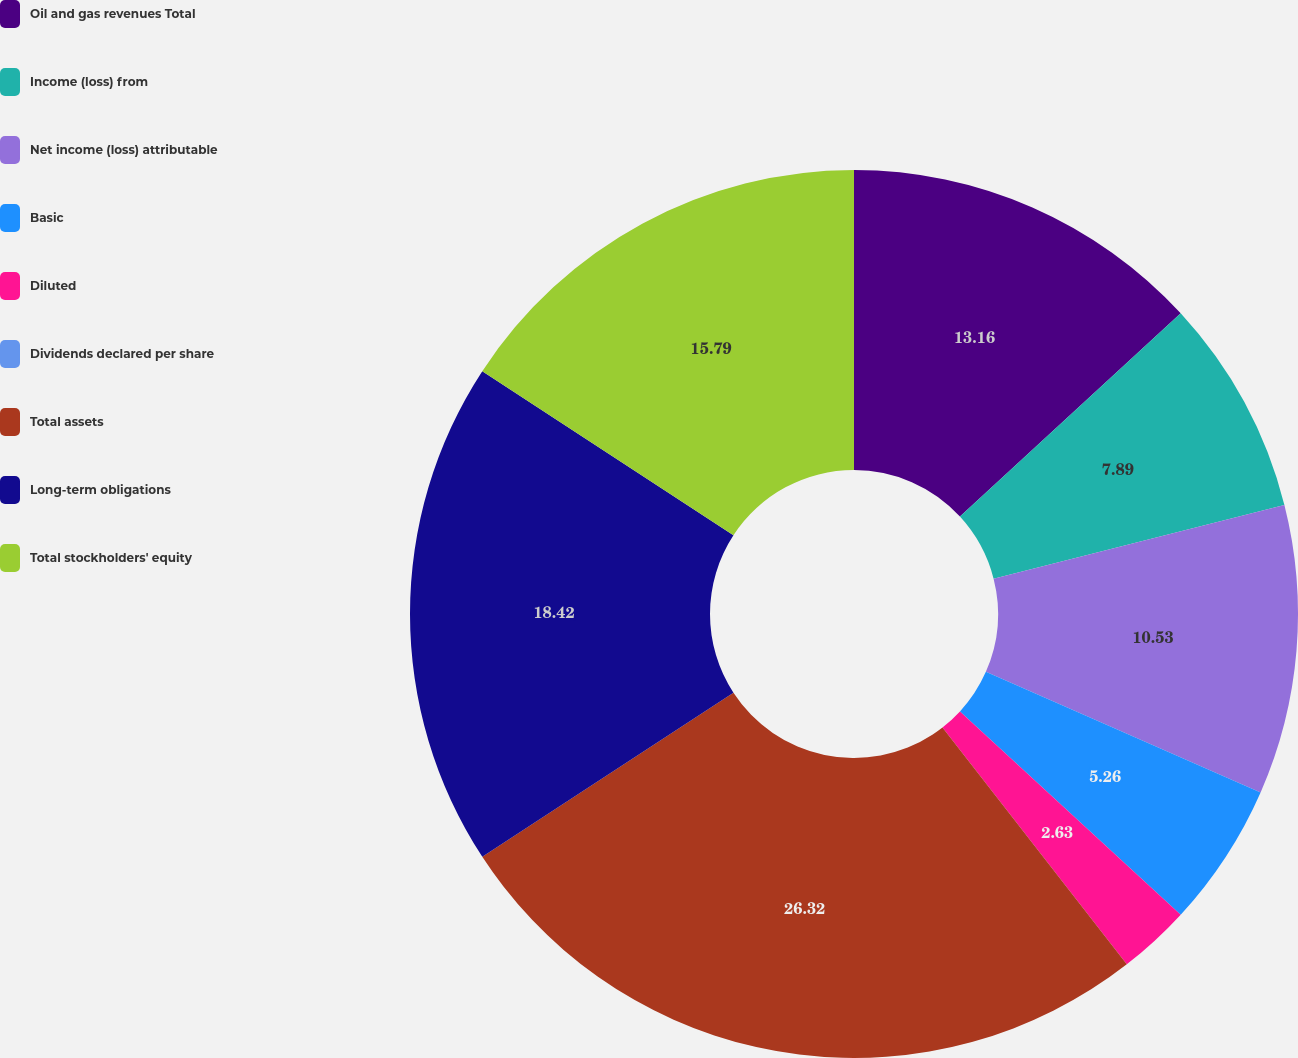<chart> <loc_0><loc_0><loc_500><loc_500><pie_chart><fcel>Oil and gas revenues Total<fcel>Income (loss) from<fcel>Net income (loss) attributable<fcel>Basic<fcel>Diluted<fcel>Dividends declared per share<fcel>Total assets<fcel>Long-term obligations<fcel>Total stockholders' equity<nl><fcel>13.16%<fcel>7.89%<fcel>10.53%<fcel>5.26%<fcel>2.63%<fcel>0.0%<fcel>26.32%<fcel>18.42%<fcel>15.79%<nl></chart> 